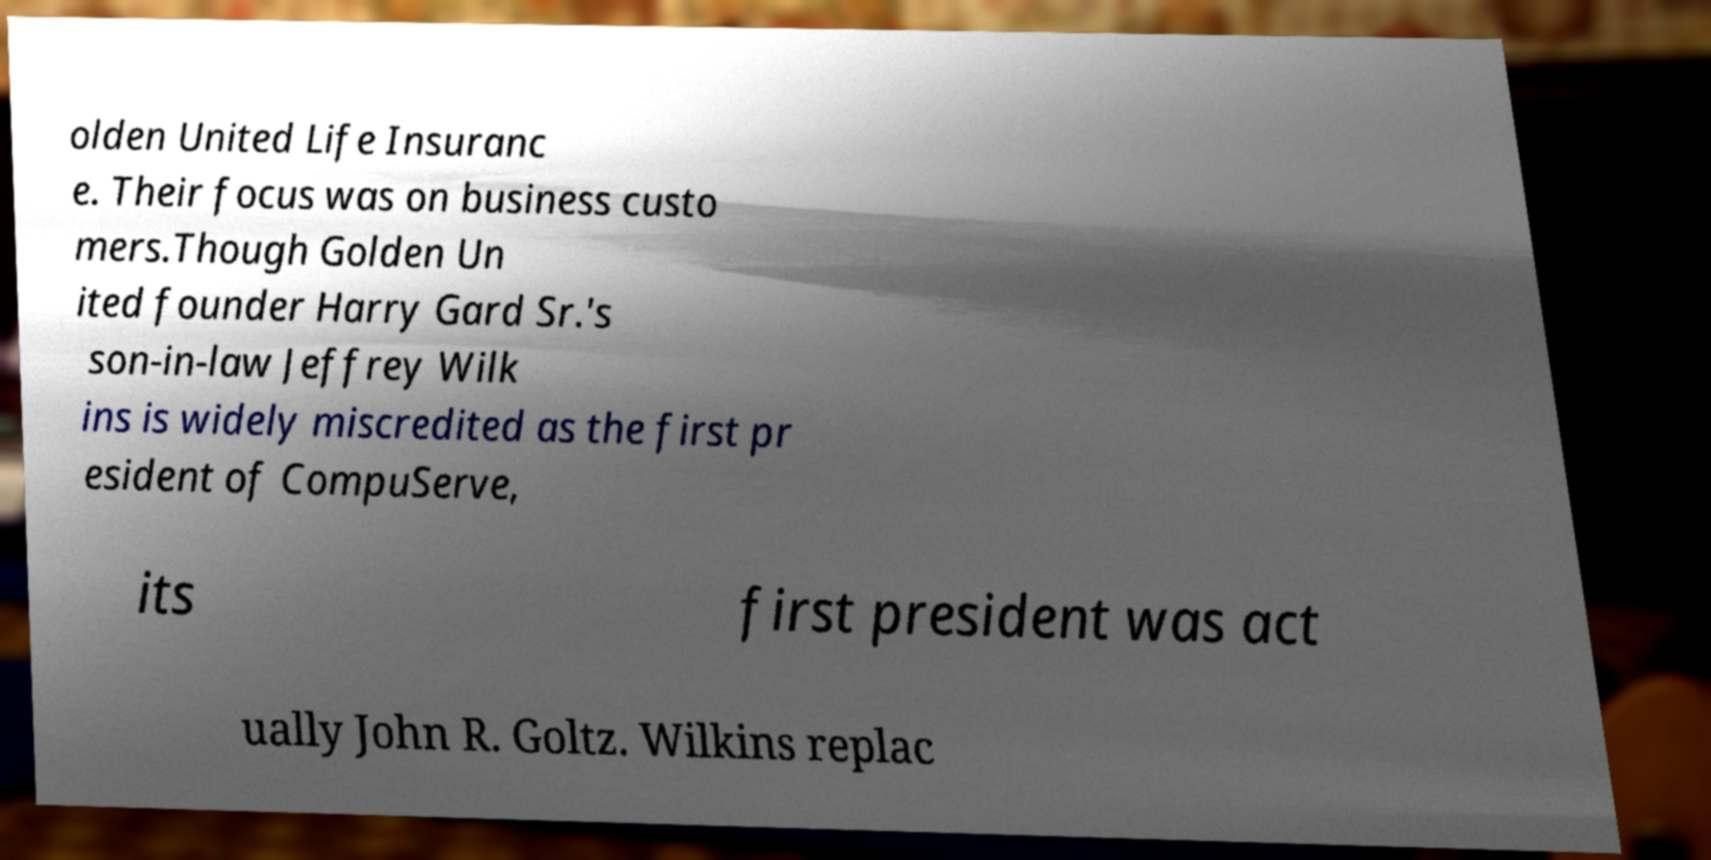Please read and relay the text visible in this image. What does it say? olden United Life Insuranc e. Their focus was on business custo mers.Though Golden Un ited founder Harry Gard Sr.'s son-in-law Jeffrey Wilk ins is widely miscredited as the first pr esident of CompuServe, its first president was act ually John R. Goltz. Wilkins replac 